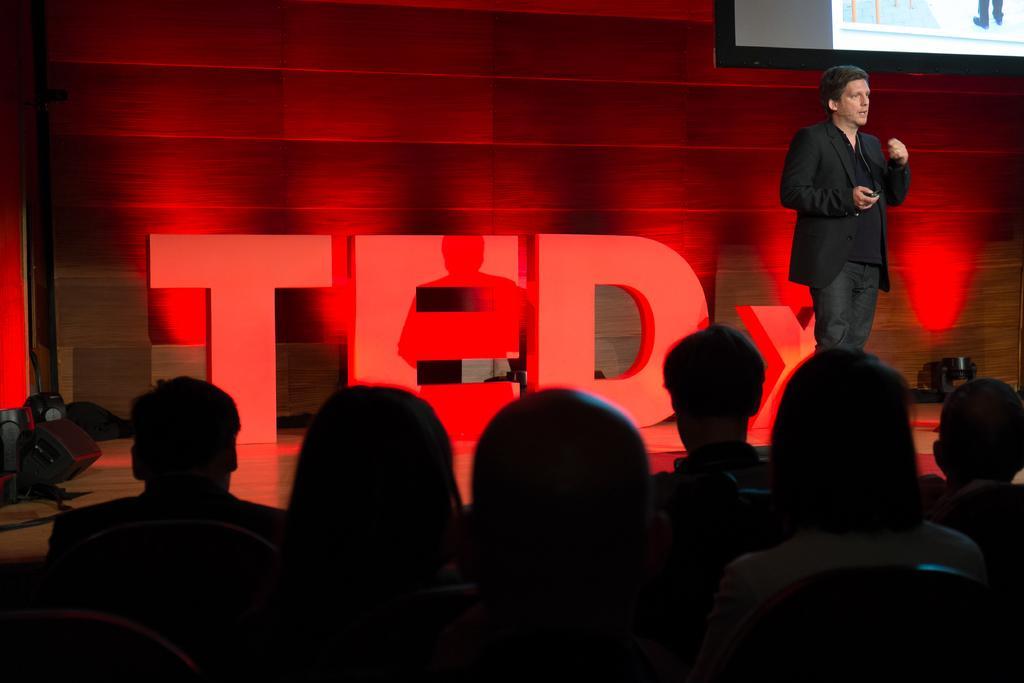Describe this image in one or two sentences. In the image there is a person in black dress standing on right side on stage and behind him there is a name board and a screen above, in the front there are few people sitting on chairs. 